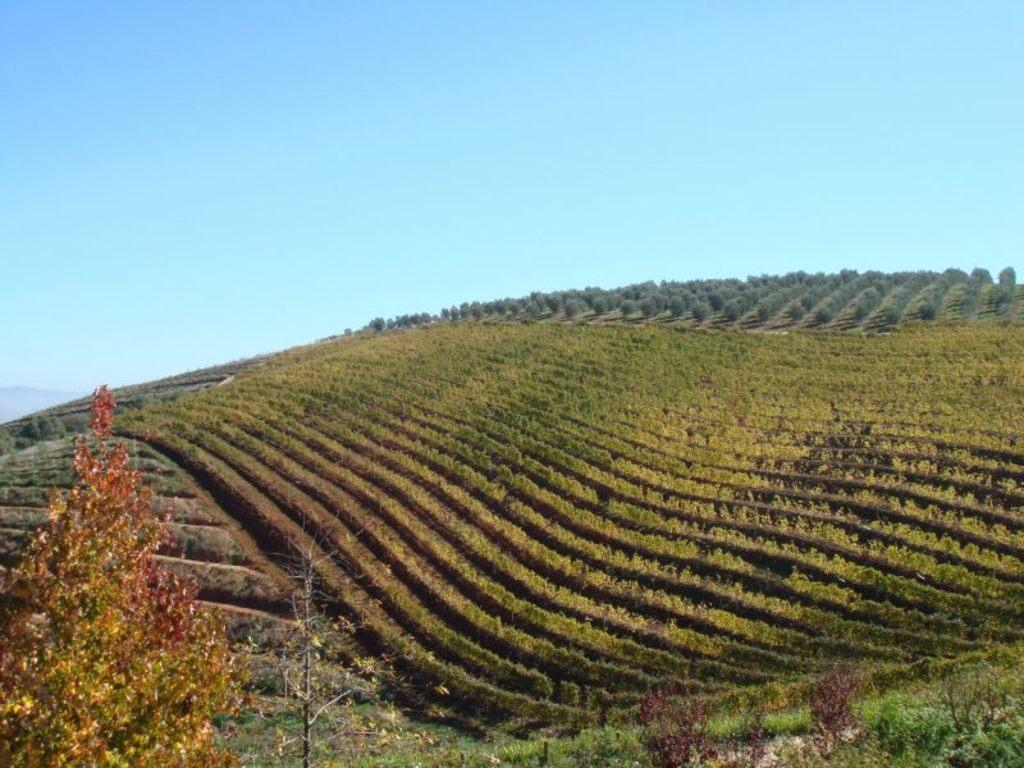What type of vegetation is present in the image? There is green grass in the image. What else can be seen in the image besides the grass? There are trees in the image. What is the color of the leaves on the trees in the image? The leaves are yellow and brown in color. What is the color of the sky in the image? The sky is blue and white in color. Can you tell me how many writers are present in the image? There are no writers present in the image; it features green grass, trees, yellow and brown leaves, and a blue and white sky. What type of burst can be seen in the image? There is no burst present in the image. 